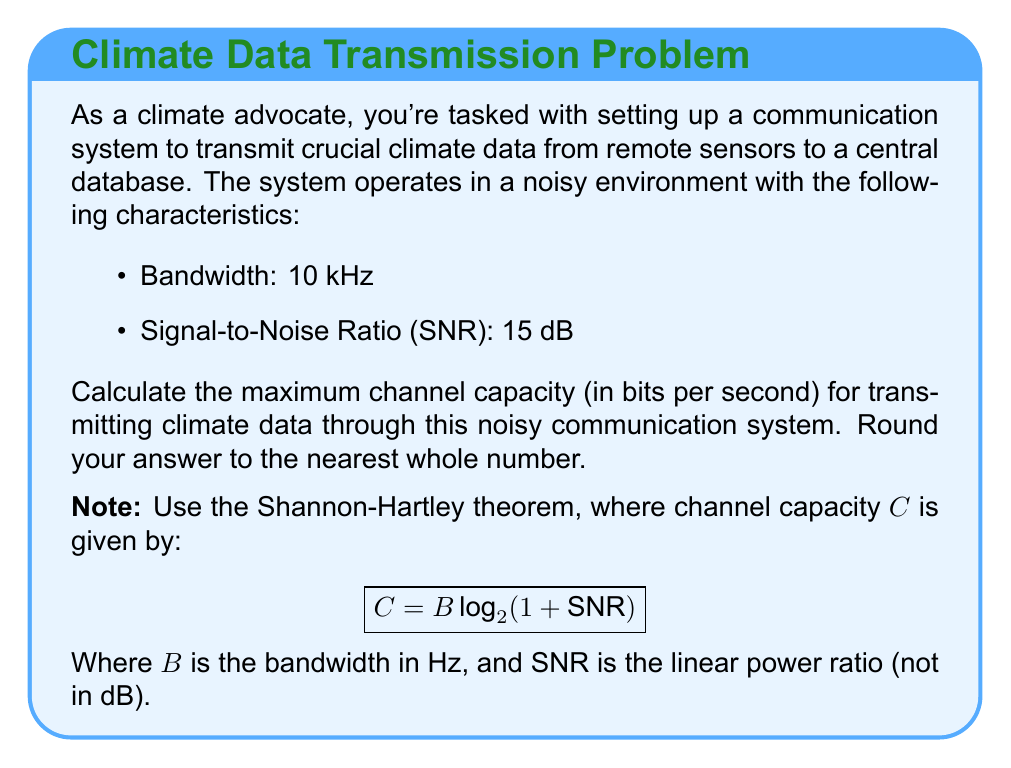What is the answer to this math problem? To solve this problem, we'll follow these steps:

1) First, we need to convert the SNR from decibels (dB) to a linear power ratio:
   $$ SNR_{linear} = 10^{\frac{SNR_{dB}}{10}} = 10^{\frac{15}{10}} = 10^{1.5} \approx 31.6228 $$

2) Now we have all the components to use in the Shannon-Hartley theorem:
   - B = 10 kHz = 10,000 Hz
   - SNR (linear) ≈ 31.6228

3) Let's apply the Shannon-Hartley theorem:
   $$ C = B \log_2(1 + SNR) $$
   $$ C = 10,000 \log_2(1 + 31.6228) $$

4) Calculate the logarithm:
   $$ \log_2(1 + 31.6228) \approx 5.0 $$

5) Multiply by the bandwidth:
   $$ C = 10,000 * 5.0 = 50,000 \text{ bits per second} $$

6) Rounding to the nearest whole number:
   $$ C \approx 50,000 \text{ bps} $$

This channel capacity represents the theoretical maximum rate at which data can be transmitted over this noisy channel without error, which is crucial for ensuring accurate climate data transmission.
Answer: 50,000 bps 